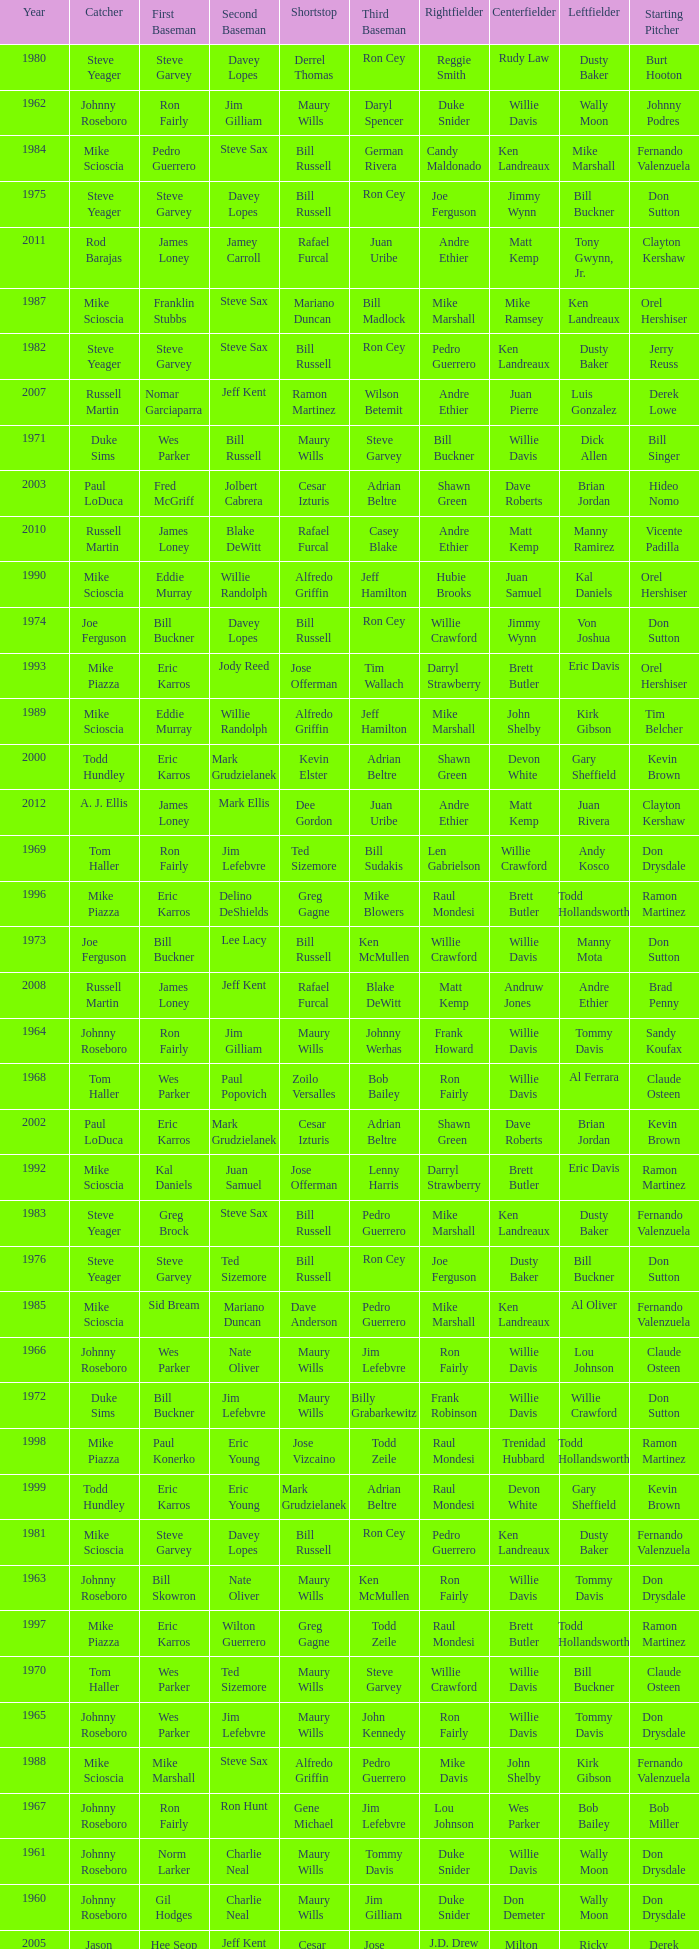Who played 2nd base when nomar garciaparra was at 1st base? Jeff Kent. 